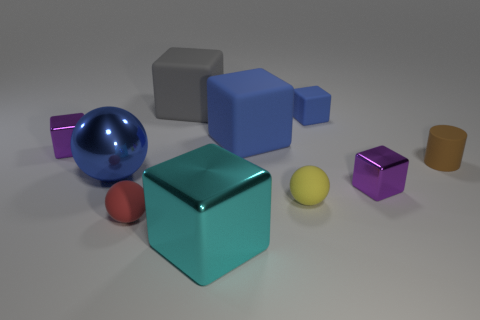How many blue things are either tiny cubes or large metallic blocks?
Give a very brief answer. 1. Are there more tiny metallic objects that are in front of the blue metal thing than big gray cubes?
Keep it short and to the point. No. Is the blue metal sphere the same size as the gray thing?
Give a very brief answer. Yes. There is a small cube that is made of the same material as the small cylinder; what color is it?
Keep it short and to the point. Blue. There is a large matte object that is the same color as the big ball; what shape is it?
Your answer should be compact. Cube. Is the number of tiny rubber cubes that are in front of the large blue rubber object the same as the number of gray matte blocks that are left of the tiny brown thing?
Your answer should be very brief. No. There is a small purple thing to the left of the blue object on the left side of the big gray rubber block; what shape is it?
Your response must be concise. Cube. What is the material of the large blue thing that is the same shape as the big gray thing?
Ensure brevity in your answer.  Rubber. What is the color of the shiny ball that is the same size as the cyan metallic object?
Your response must be concise. Blue. Are there the same number of tiny rubber spheres behind the small red matte object and big cubes?
Ensure brevity in your answer.  No. 